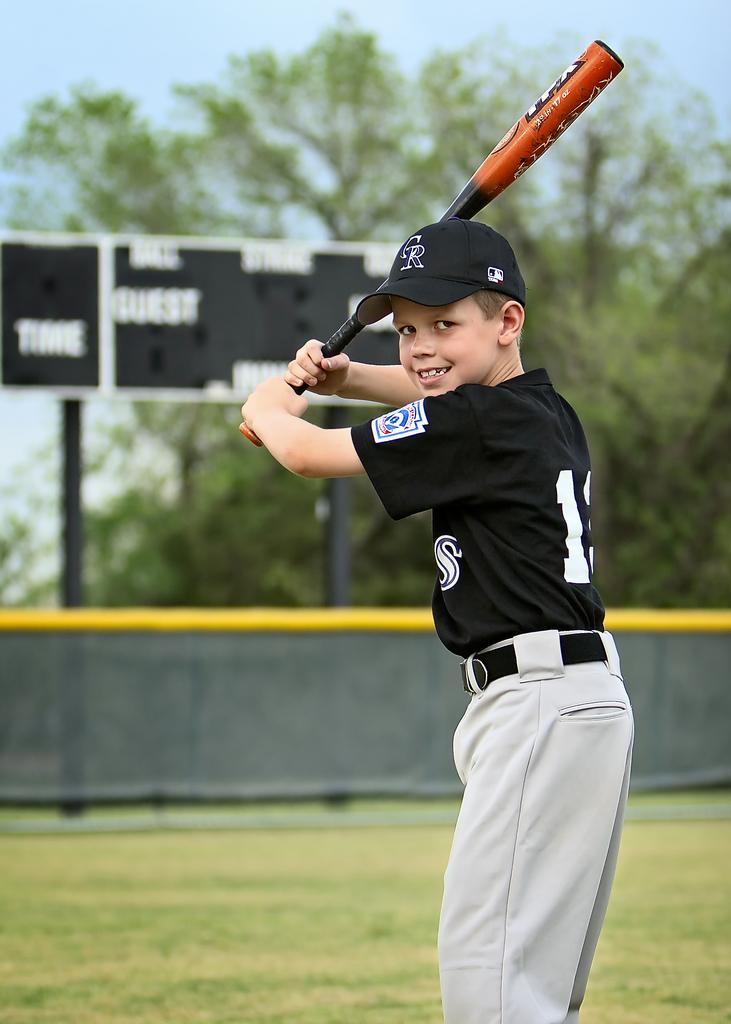What does the scoreboard say?
Provide a short and direct response. Guest. 